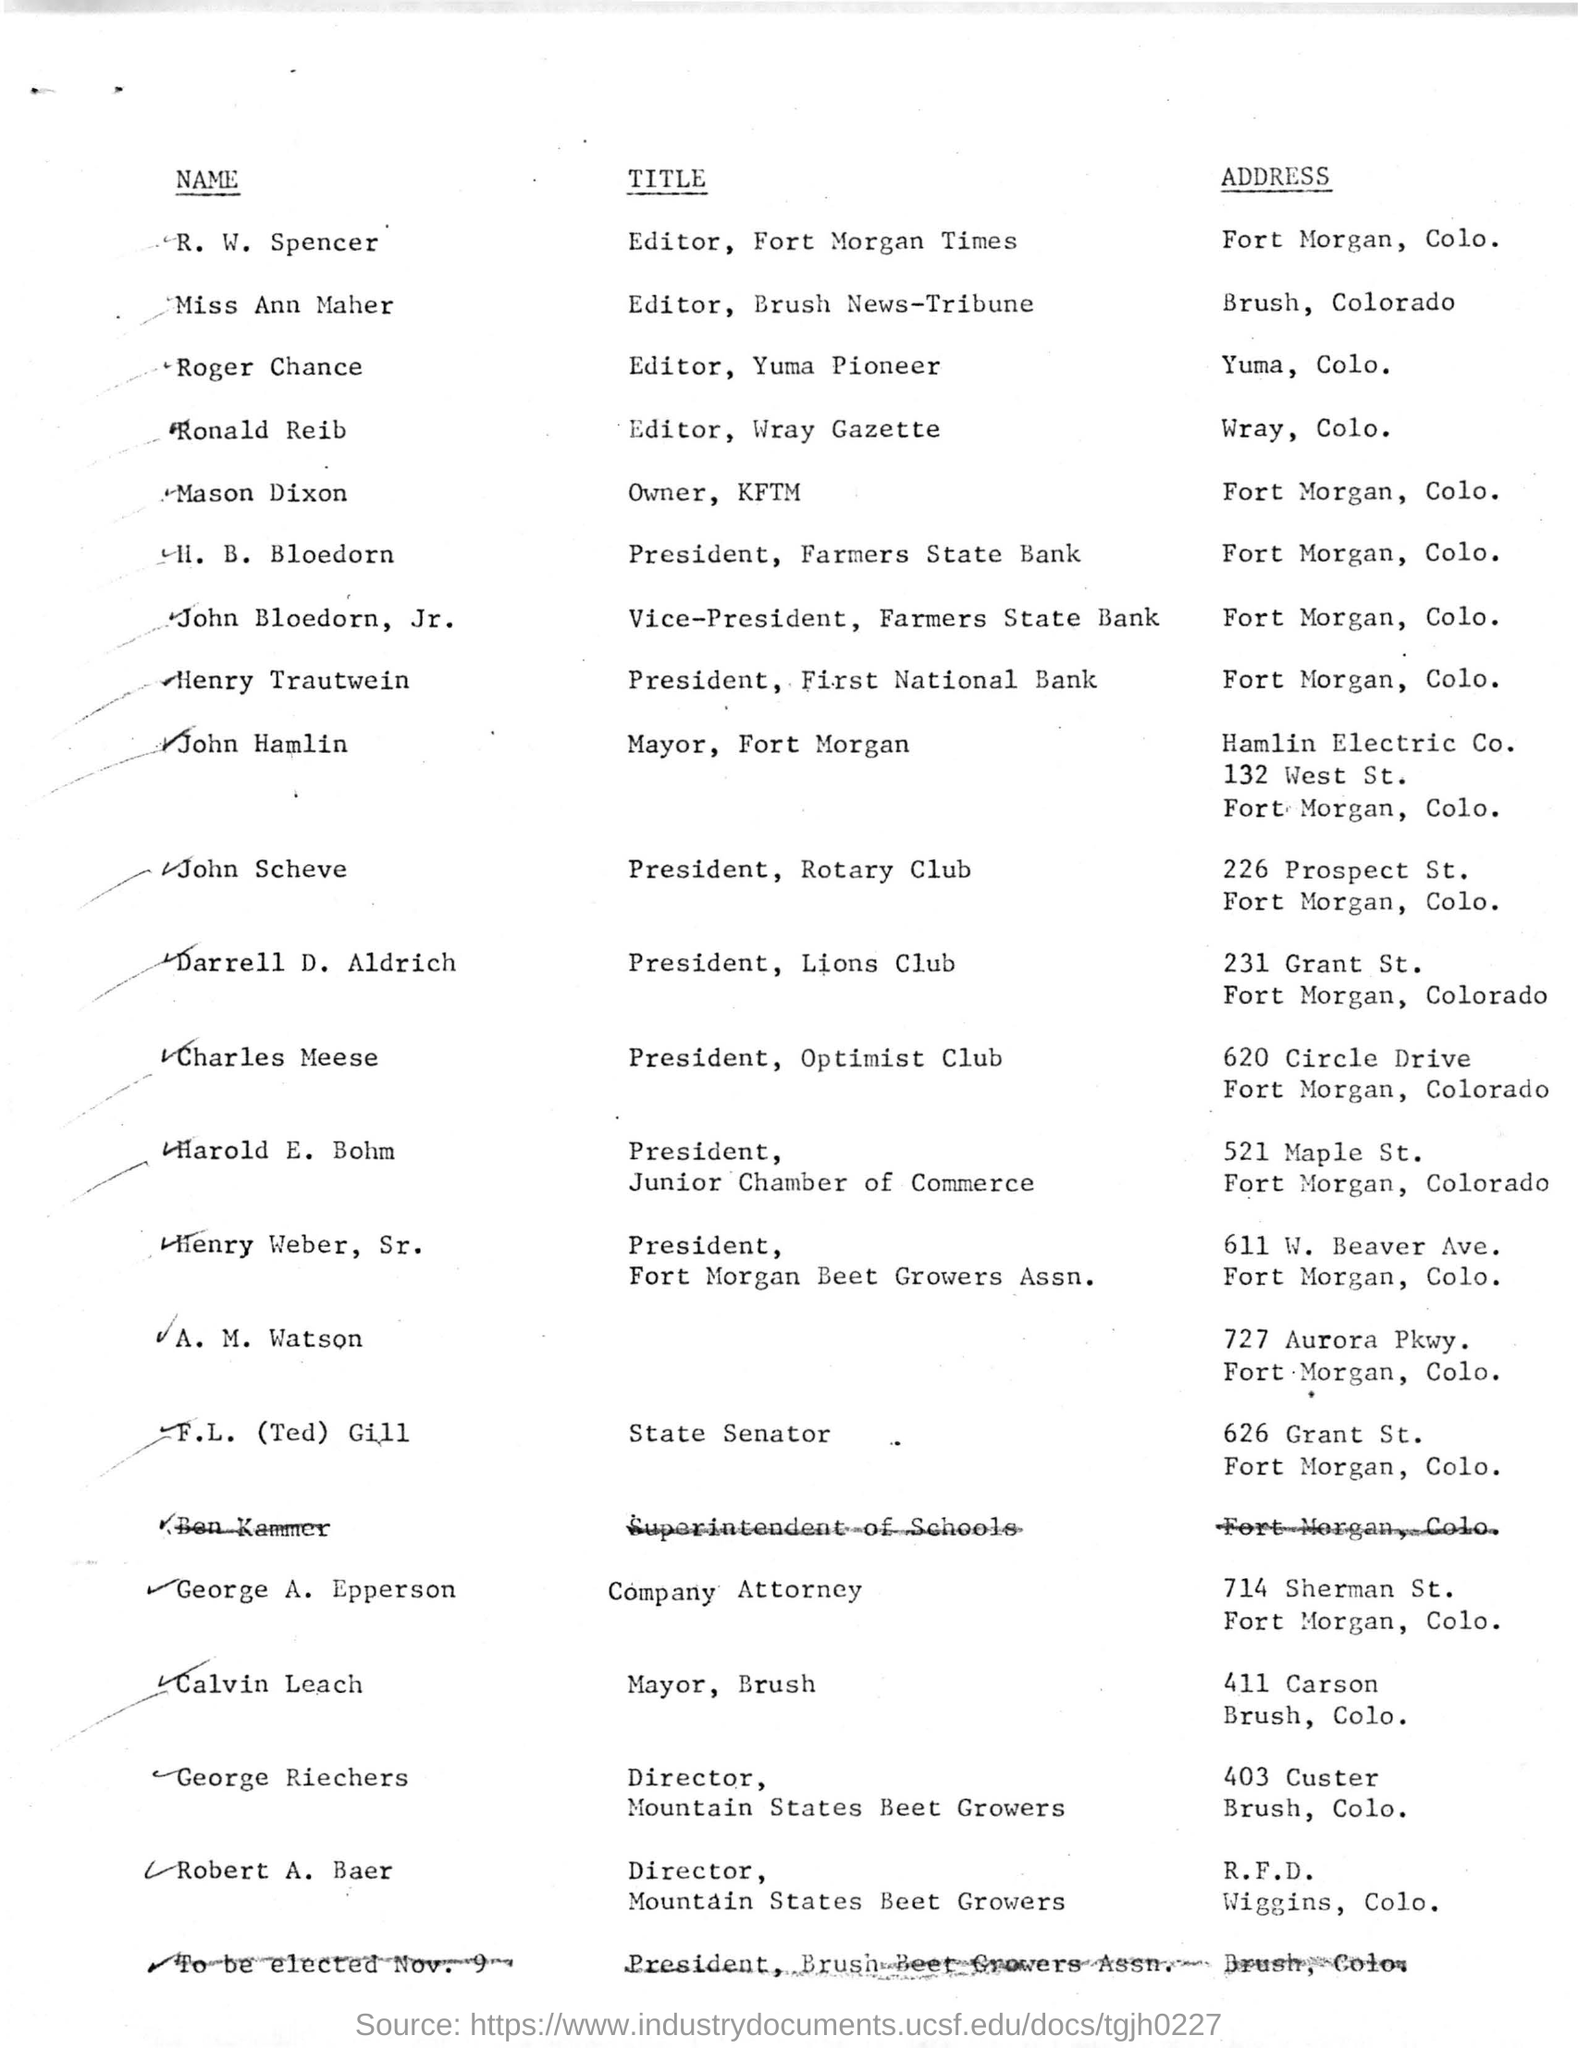What is the Title of R.W. Spencer ?
Keep it short and to the point. Editor, Fort Morgan Times. What is the address of Miss Ann Maher ?
Provide a short and direct response. Brush, Colorado. What is the name of "Owner, KFTM" ?
Make the answer very short. MASON DIXON. What is Title of Roger Chance ?
Offer a very short reply. Editor, Yuma Pioneer. What is the address of Henry Trautwein ?
Your response must be concise. Fort Morgan, Colo. What is the Title of John Hamlin ?
Your answer should be very brief. Mayor, Fort Morgan. 